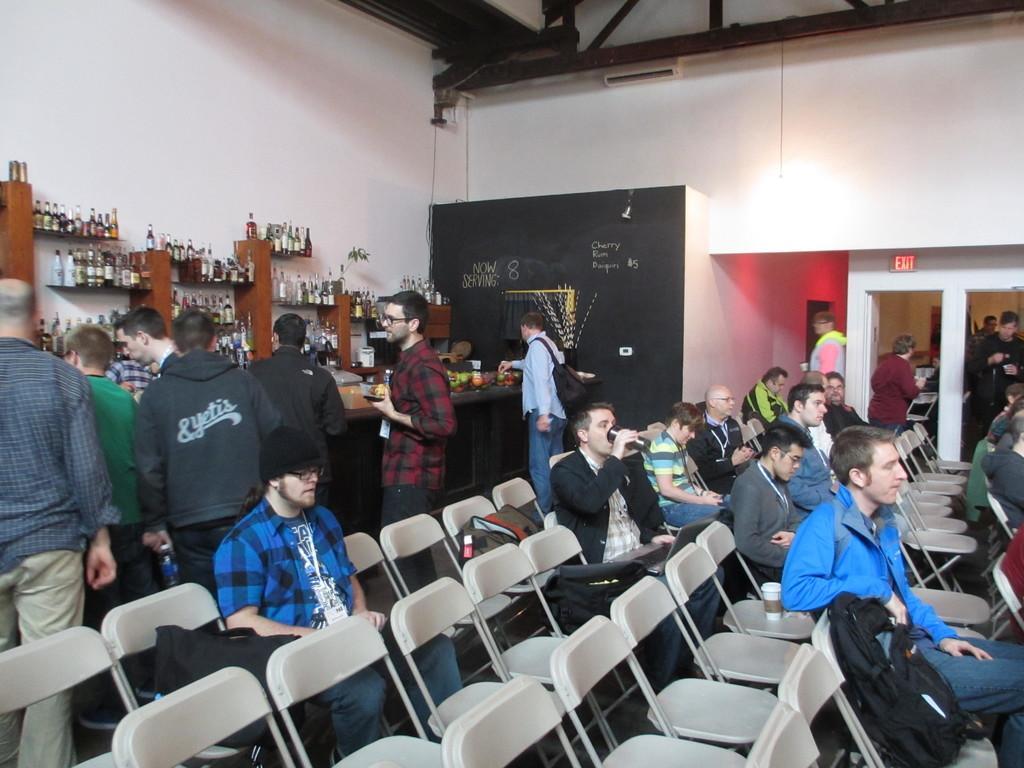Describe this image in one or two sentences. In this image, there are some persons wearing clothes and sitting on chairs. There are some other persons wearing clothes and standing in front of bottle racks. There are some chairs at the bottom of the image. 